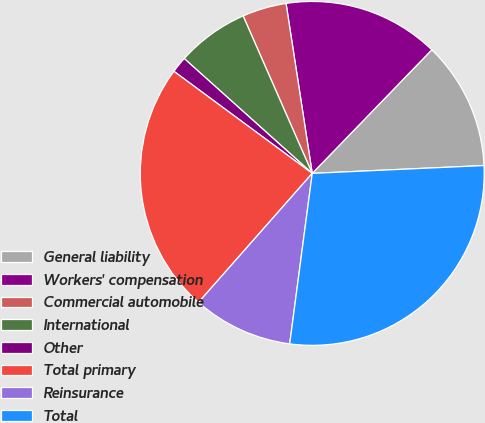<chart> <loc_0><loc_0><loc_500><loc_500><pie_chart><fcel>General liability<fcel>Workers' compensation<fcel>Commercial automobile<fcel>International<fcel>Other<fcel>Total primary<fcel>Reinsurance<fcel>Total<nl><fcel>12.04%<fcel>14.67%<fcel>4.15%<fcel>6.78%<fcel>1.52%<fcel>23.62%<fcel>9.41%<fcel>27.82%<nl></chart> 